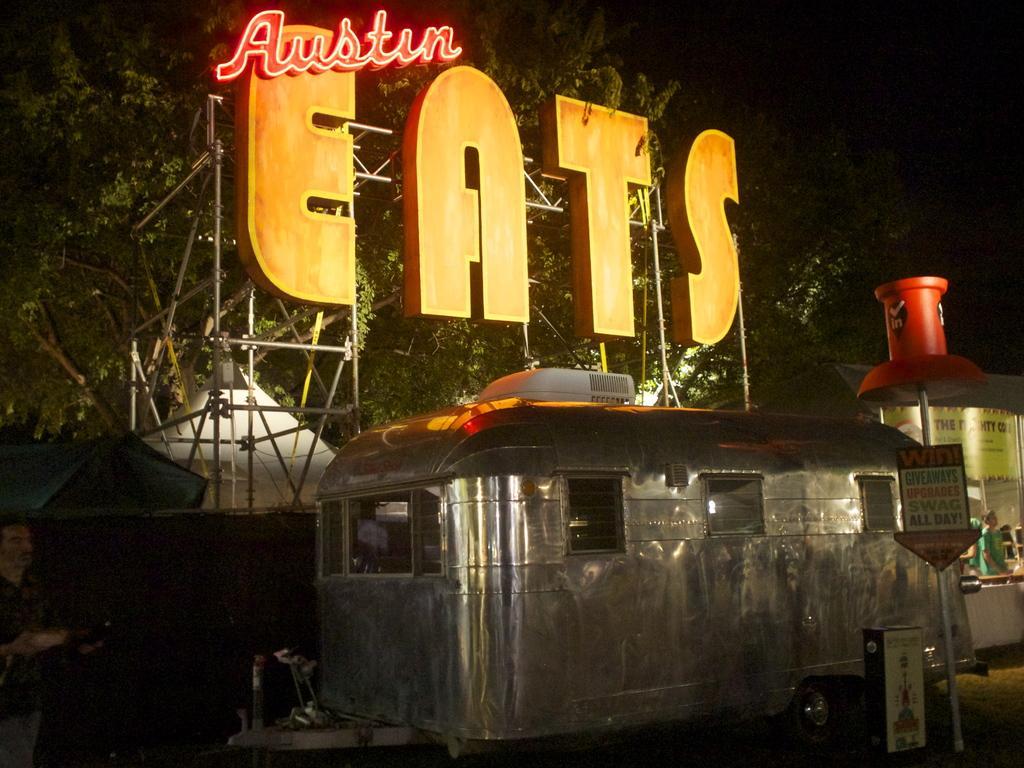Please provide a concise description of this image. At the bottom of this image, there is a vehicle on the road. On the right side, there is a signboard attached to a pole. Beside this pole, there is a hoarding. In the background, there is a hoarding, there are trees, shelters and a person. And the background is dark in color. 